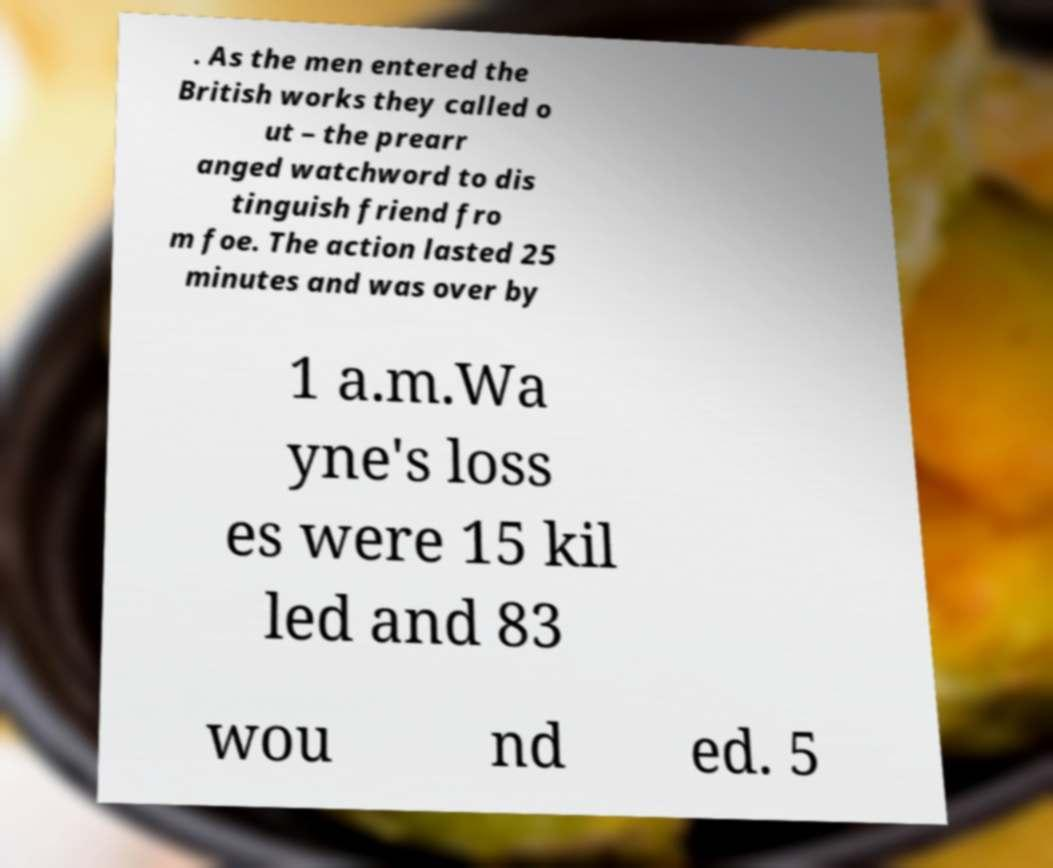I need the written content from this picture converted into text. Can you do that? . As the men entered the British works they called o ut – the prearr anged watchword to dis tinguish friend fro m foe. The action lasted 25 minutes and was over by 1 a.m.Wa yne's loss es were 15 kil led and 83 wou nd ed. 5 